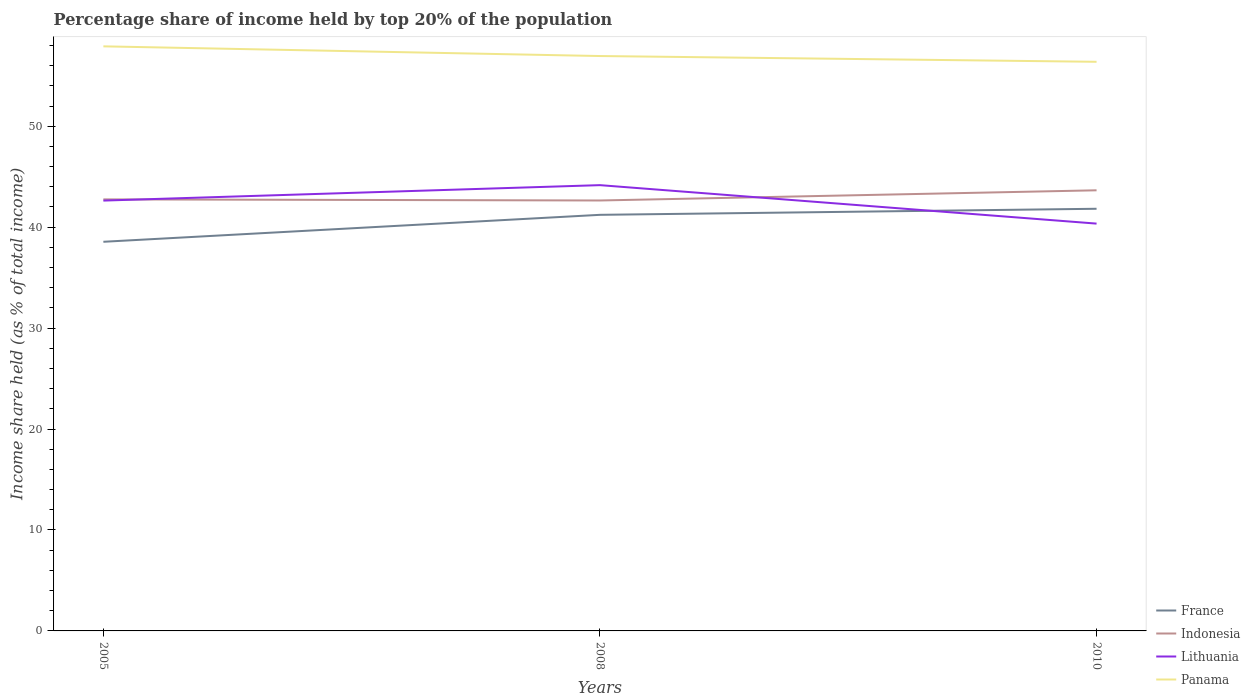Is the number of lines equal to the number of legend labels?
Keep it short and to the point. Yes. Across all years, what is the maximum percentage share of income held by top 20% of the population in Lithuania?
Make the answer very short. 40.35. In which year was the percentage share of income held by top 20% of the population in Panama maximum?
Your response must be concise. 2010. What is the total percentage share of income held by top 20% of the population in Indonesia in the graph?
Provide a succinct answer. -0.9. What is the difference between the highest and the second highest percentage share of income held by top 20% of the population in France?
Provide a short and direct response. 3.27. How many years are there in the graph?
Give a very brief answer. 3. What is the difference between two consecutive major ticks on the Y-axis?
Your answer should be very brief. 10. Are the values on the major ticks of Y-axis written in scientific E-notation?
Your answer should be very brief. No. Does the graph contain any zero values?
Offer a very short reply. No. Does the graph contain grids?
Provide a short and direct response. No. Where does the legend appear in the graph?
Keep it short and to the point. Bottom right. How many legend labels are there?
Provide a short and direct response. 4. What is the title of the graph?
Your response must be concise. Percentage share of income held by top 20% of the population. What is the label or title of the Y-axis?
Ensure brevity in your answer.  Income share held (as % of total income). What is the Income share held (as % of total income) of France in 2005?
Your answer should be compact. 38.55. What is the Income share held (as % of total income) in Indonesia in 2005?
Your answer should be compact. 42.75. What is the Income share held (as % of total income) of Lithuania in 2005?
Your answer should be compact. 42.63. What is the Income share held (as % of total income) of Panama in 2005?
Offer a terse response. 57.91. What is the Income share held (as % of total income) of France in 2008?
Make the answer very short. 41.22. What is the Income share held (as % of total income) of Indonesia in 2008?
Your response must be concise. 42.64. What is the Income share held (as % of total income) in Lithuania in 2008?
Your answer should be compact. 44.16. What is the Income share held (as % of total income) in Panama in 2008?
Your response must be concise. 56.95. What is the Income share held (as % of total income) of France in 2010?
Provide a succinct answer. 41.82. What is the Income share held (as % of total income) of Indonesia in 2010?
Make the answer very short. 43.65. What is the Income share held (as % of total income) in Lithuania in 2010?
Keep it short and to the point. 40.35. What is the Income share held (as % of total income) in Panama in 2010?
Provide a succinct answer. 56.38. Across all years, what is the maximum Income share held (as % of total income) in France?
Your answer should be very brief. 41.82. Across all years, what is the maximum Income share held (as % of total income) in Indonesia?
Keep it short and to the point. 43.65. Across all years, what is the maximum Income share held (as % of total income) of Lithuania?
Ensure brevity in your answer.  44.16. Across all years, what is the maximum Income share held (as % of total income) in Panama?
Provide a short and direct response. 57.91. Across all years, what is the minimum Income share held (as % of total income) of France?
Offer a terse response. 38.55. Across all years, what is the minimum Income share held (as % of total income) in Indonesia?
Provide a short and direct response. 42.64. Across all years, what is the minimum Income share held (as % of total income) of Lithuania?
Your answer should be compact. 40.35. Across all years, what is the minimum Income share held (as % of total income) of Panama?
Your response must be concise. 56.38. What is the total Income share held (as % of total income) in France in the graph?
Give a very brief answer. 121.59. What is the total Income share held (as % of total income) in Indonesia in the graph?
Ensure brevity in your answer.  129.04. What is the total Income share held (as % of total income) of Lithuania in the graph?
Make the answer very short. 127.14. What is the total Income share held (as % of total income) of Panama in the graph?
Keep it short and to the point. 171.24. What is the difference between the Income share held (as % of total income) in France in 2005 and that in 2008?
Keep it short and to the point. -2.67. What is the difference between the Income share held (as % of total income) of Indonesia in 2005 and that in 2008?
Ensure brevity in your answer.  0.11. What is the difference between the Income share held (as % of total income) in Lithuania in 2005 and that in 2008?
Ensure brevity in your answer.  -1.53. What is the difference between the Income share held (as % of total income) in France in 2005 and that in 2010?
Provide a short and direct response. -3.27. What is the difference between the Income share held (as % of total income) of Lithuania in 2005 and that in 2010?
Ensure brevity in your answer.  2.28. What is the difference between the Income share held (as % of total income) in Panama in 2005 and that in 2010?
Ensure brevity in your answer.  1.53. What is the difference between the Income share held (as % of total income) in Indonesia in 2008 and that in 2010?
Offer a very short reply. -1.01. What is the difference between the Income share held (as % of total income) in Lithuania in 2008 and that in 2010?
Your response must be concise. 3.81. What is the difference between the Income share held (as % of total income) in Panama in 2008 and that in 2010?
Provide a short and direct response. 0.57. What is the difference between the Income share held (as % of total income) of France in 2005 and the Income share held (as % of total income) of Indonesia in 2008?
Ensure brevity in your answer.  -4.09. What is the difference between the Income share held (as % of total income) of France in 2005 and the Income share held (as % of total income) of Lithuania in 2008?
Offer a terse response. -5.61. What is the difference between the Income share held (as % of total income) in France in 2005 and the Income share held (as % of total income) in Panama in 2008?
Your answer should be compact. -18.4. What is the difference between the Income share held (as % of total income) in Indonesia in 2005 and the Income share held (as % of total income) in Lithuania in 2008?
Offer a very short reply. -1.41. What is the difference between the Income share held (as % of total income) in Lithuania in 2005 and the Income share held (as % of total income) in Panama in 2008?
Offer a very short reply. -14.32. What is the difference between the Income share held (as % of total income) in France in 2005 and the Income share held (as % of total income) in Indonesia in 2010?
Offer a terse response. -5.1. What is the difference between the Income share held (as % of total income) of France in 2005 and the Income share held (as % of total income) of Lithuania in 2010?
Your answer should be compact. -1.8. What is the difference between the Income share held (as % of total income) in France in 2005 and the Income share held (as % of total income) in Panama in 2010?
Keep it short and to the point. -17.83. What is the difference between the Income share held (as % of total income) of Indonesia in 2005 and the Income share held (as % of total income) of Panama in 2010?
Ensure brevity in your answer.  -13.63. What is the difference between the Income share held (as % of total income) of Lithuania in 2005 and the Income share held (as % of total income) of Panama in 2010?
Offer a very short reply. -13.75. What is the difference between the Income share held (as % of total income) of France in 2008 and the Income share held (as % of total income) of Indonesia in 2010?
Provide a short and direct response. -2.43. What is the difference between the Income share held (as % of total income) of France in 2008 and the Income share held (as % of total income) of Lithuania in 2010?
Ensure brevity in your answer.  0.87. What is the difference between the Income share held (as % of total income) in France in 2008 and the Income share held (as % of total income) in Panama in 2010?
Ensure brevity in your answer.  -15.16. What is the difference between the Income share held (as % of total income) in Indonesia in 2008 and the Income share held (as % of total income) in Lithuania in 2010?
Your answer should be compact. 2.29. What is the difference between the Income share held (as % of total income) in Indonesia in 2008 and the Income share held (as % of total income) in Panama in 2010?
Your answer should be compact. -13.74. What is the difference between the Income share held (as % of total income) in Lithuania in 2008 and the Income share held (as % of total income) in Panama in 2010?
Make the answer very short. -12.22. What is the average Income share held (as % of total income) in France per year?
Offer a terse response. 40.53. What is the average Income share held (as % of total income) of Indonesia per year?
Provide a succinct answer. 43.01. What is the average Income share held (as % of total income) in Lithuania per year?
Keep it short and to the point. 42.38. What is the average Income share held (as % of total income) in Panama per year?
Your response must be concise. 57.08. In the year 2005, what is the difference between the Income share held (as % of total income) of France and Income share held (as % of total income) of Indonesia?
Offer a terse response. -4.2. In the year 2005, what is the difference between the Income share held (as % of total income) of France and Income share held (as % of total income) of Lithuania?
Keep it short and to the point. -4.08. In the year 2005, what is the difference between the Income share held (as % of total income) of France and Income share held (as % of total income) of Panama?
Your answer should be compact. -19.36. In the year 2005, what is the difference between the Income share held (as % of total income) in Indonesia and Income share held (as % of total income) in Lithuania?
Provide a short and direct response. 0.12. In the year 2005, what is the difference between the Income share held (as % of total income) in Indonesia and Income share held (as % of total income) in Panama?
Your answer should be very brief. -15.16. In the year 2005, what is the difference between the Income share held (as % of total income) in Lithuania and Income share held (as % of total income) in Panama?
Your answer should be very brief. -15.28. In the year 2008, what is the difference between the Income share held (as % of total income) in France and Income share held (as % of total income) in Indonesia?
Offer a very short reply. -1.42. In the year 2008, what is the difference between the Income share held (as % of total income) in France and Income share held (as % of total income) in Lithuania?
Your answer should be very brief. -2.94. In the year 2008, what is the difference between the Income share held (as % of total income) in France and Income share held (as % of total income) in Panama?
Your answer should be very brief. -15.73. In the year 2008, what is the difference between the Income share held (as % of total income) in Indonesia and Income share held (as % of total income) in Lithuania?
Your answer should be compact. -1.52. In the year 2008, what is the difference between the Income share held (as % of total income) of Indonesia and Income share held (as % of total income) of Panama?
Ensure brevity in your answer.  -14.31. In the year 2008, what is the difference between the Income share held (as % of total income) in Lithuania and Income share held (as % of total income) in Panama?
Your answer should be compact. -12.79. In the year 2010, what is the difference between the Income share held (as % of total income) in France and Income share held (as % of total income) in Indonesia?
Offer a terse response. -1.83. In the year 2010, what is the difference between the Income share held (as % of total income) of France and Income share held (as % of total income) of Lithuania?
Give a very brief answer. 1.47. In the year 2010, what is the difference between the Income share held (as % of total income) in France and Income share held (as % of total income) in Panama?
Provide a short and direct response. -14.56. In the year 2010, what is the difference between the Income share held (as % of total income) in Indonesia and Income share held (as % of total income) in Lithuania?
Your answer should be very brief. 3.3. In the year 2010, what is the difference between the Income share held (as % of total income) in Indonesia and Income share held (as % of total income) in Panama?
Provide a succinct answer. -12.73. In the year 2010, what is the difference between the Income share held (as % of total income) in Lithuania and Income share held (as % of total income) in Panama?
Ensure brevity in your answer.  -16.03. What is the ratio of the Income share held (as % of total income) of France in 2005 to that in 2008?
Give a very brief answer. 0.94. What is the ratio of the Income share held (as % of total income) of Indonesia in 2005 to that in 2008?
Provide a succinct answer. 1. What is the ratio of the Income share held (as % of total income) of Lithuania in 2005 to that in 2008?
Your answer should be very brief. 0.97. What is the ratio of the Income share held (as % of total income) of Panama in 2005 to that in 2008?
Make the answer very short. 1.02. What is the ratio of the Income share held (as % of total income) in France in 2005 to that in 2010?
Offer a very short reply. 0.92. What is the ratio of the Income share held (as % of total income) of Indonesia in 2005 to that in 2010?
Offer a terse response. 0.98. What is the ratio of the Income share held (as % of total income) of Lithuania in 2005 to that in 2010?
Offer a terse response. 1.06. What is the ratio of the Income share held (as % of total income) in Panama in 2005 to that in 2010?
Give a very brief answer. 1.03. What is the ratio of the Income share held (as % of total income) in France in 2008 to that in 2010?
Your answer should be very brief. 0.99. What is the ratio of the Income share held (as % of total income) of Indonesia in 2008 to that in 2010?
Provide a succinct answer. 0.98. What is the ratio of the Income share held (as % of total income) in Lithuania in 2008 to that in 2010?
Your answer should be very brief. 1.09. What is the ratio of the Income share held (as % of total income) of Panama in 2008 to that in 2010?
Provide a short and direct response. 1.01. What is the difference between the highest and the second highest Income share held (as % of total income) of France?
Give a very brief answer. 0.6. What is the difference between the highest and the second highest Income share held (as % of total income) of Lithuania?
Your answer should be compact. 1.53. What is the difference between the highest and the lowest Income share held (as % of total income) of France?
Ensure brevity in your answer.  3.27. What is the difference between the highest and the lowest Income share held (as % of total income) in Indonesia?
Provide a succinct answer. 1.01. What is the difference between the highest and the lowest Income share held (as % of total income) in Lithuania?
Your answer should be very brief. 3.81. What is the difference between the highest and the lowest Income share held (as % of total income) of Panama?
Your response must be concise. 1.53. 